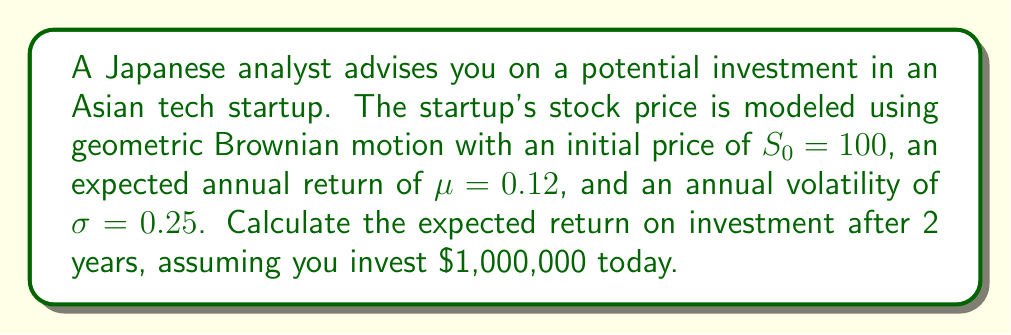Could you help me with this problem? Let's approach this step-by-step:

1) The geometric Brownian motion model for stock price is given by:

   $$S_t = S_0 \exp\left(\left(\mu - \frac{\sigma^2}{2}\right)t + \sigma W_t\right)$$

   where $W_t$ is a Wiener process.

2) The expected value of $S_t$ is:

   $$E[S_t] = S_0 \exp(\mu t)$$

3) In this case:
   $S_0 = 100$
   $\mu = 0.12$
   $t = 2$ years

4) Plugging these values into the formula:

   $$E[S_2] = 100 \exp(0.12 \times 2) = 100 \exp(0.24) \approx 127.12$$

5) This means that after 2 years, each share is expected to be worth $127.12.

6) The initial investment of $1,000,000 would buy $1,000,000 / 100 = 10,000$ shares.

7) After 2 years, these 10,000 shares are expected to be worth:

   $$10,000 \times 127.12 = 1,271,200$$

8) The expected return is the difference between this value and the initial investment:

   $$1,271,200 - 1,000,000 = 271,200$$

9) To express this as a percentage:

   $$\frac{271,200}{1,000,000} \times 100\% = 27.12\%$$

Therefore, the expected return on investment after 2 years is $271,200, or 27.12%.
Answer: $271,200 or 27.12% 